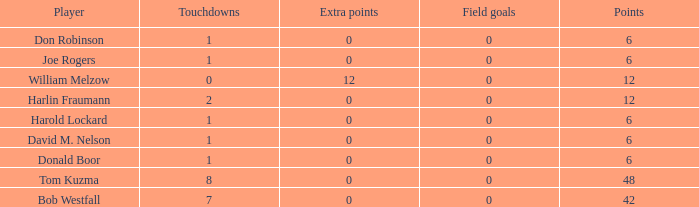Name the least touchdowns for joe rogers 1.0. 